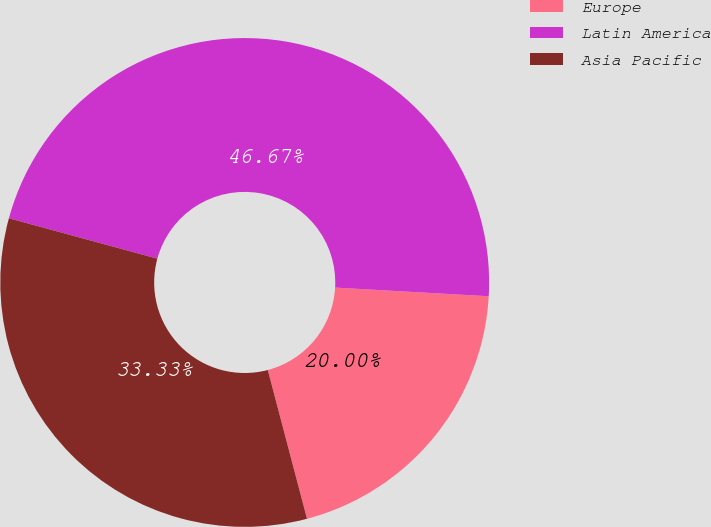<chart> <loc_0><loc_0><loc_500><loc_500><pie_chart><fcel>Europe<fcel>Latin America<fcel>Asia Pacific<nl><fcel>20.0%<fcel>46.67%<fcel>33.33%<nl></chart> 